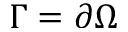<formula> <loc_0><loc_0><loc_500><loc_500>\Gamma = \partial \Omega</formula> 